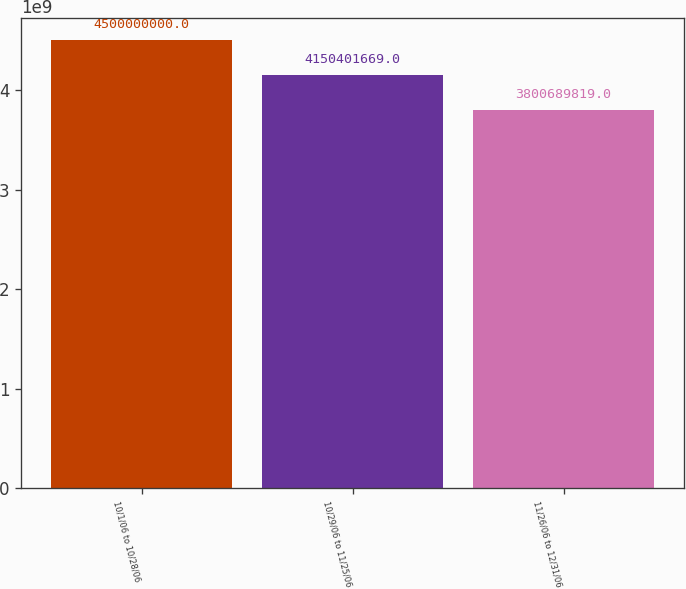Convert chart. <chart><loc_0><loc_0><loc_500><loc_500><bar_chart><fcel>10/1/06 to 10/28/06<fcel>10/29/06 to 11/25/06<fcel>11/26/06 to 12/31/06<nl><fcel>4.5e+09<fcel>4.1504e+09<fcel>3.80069e+09<nl></chart> 